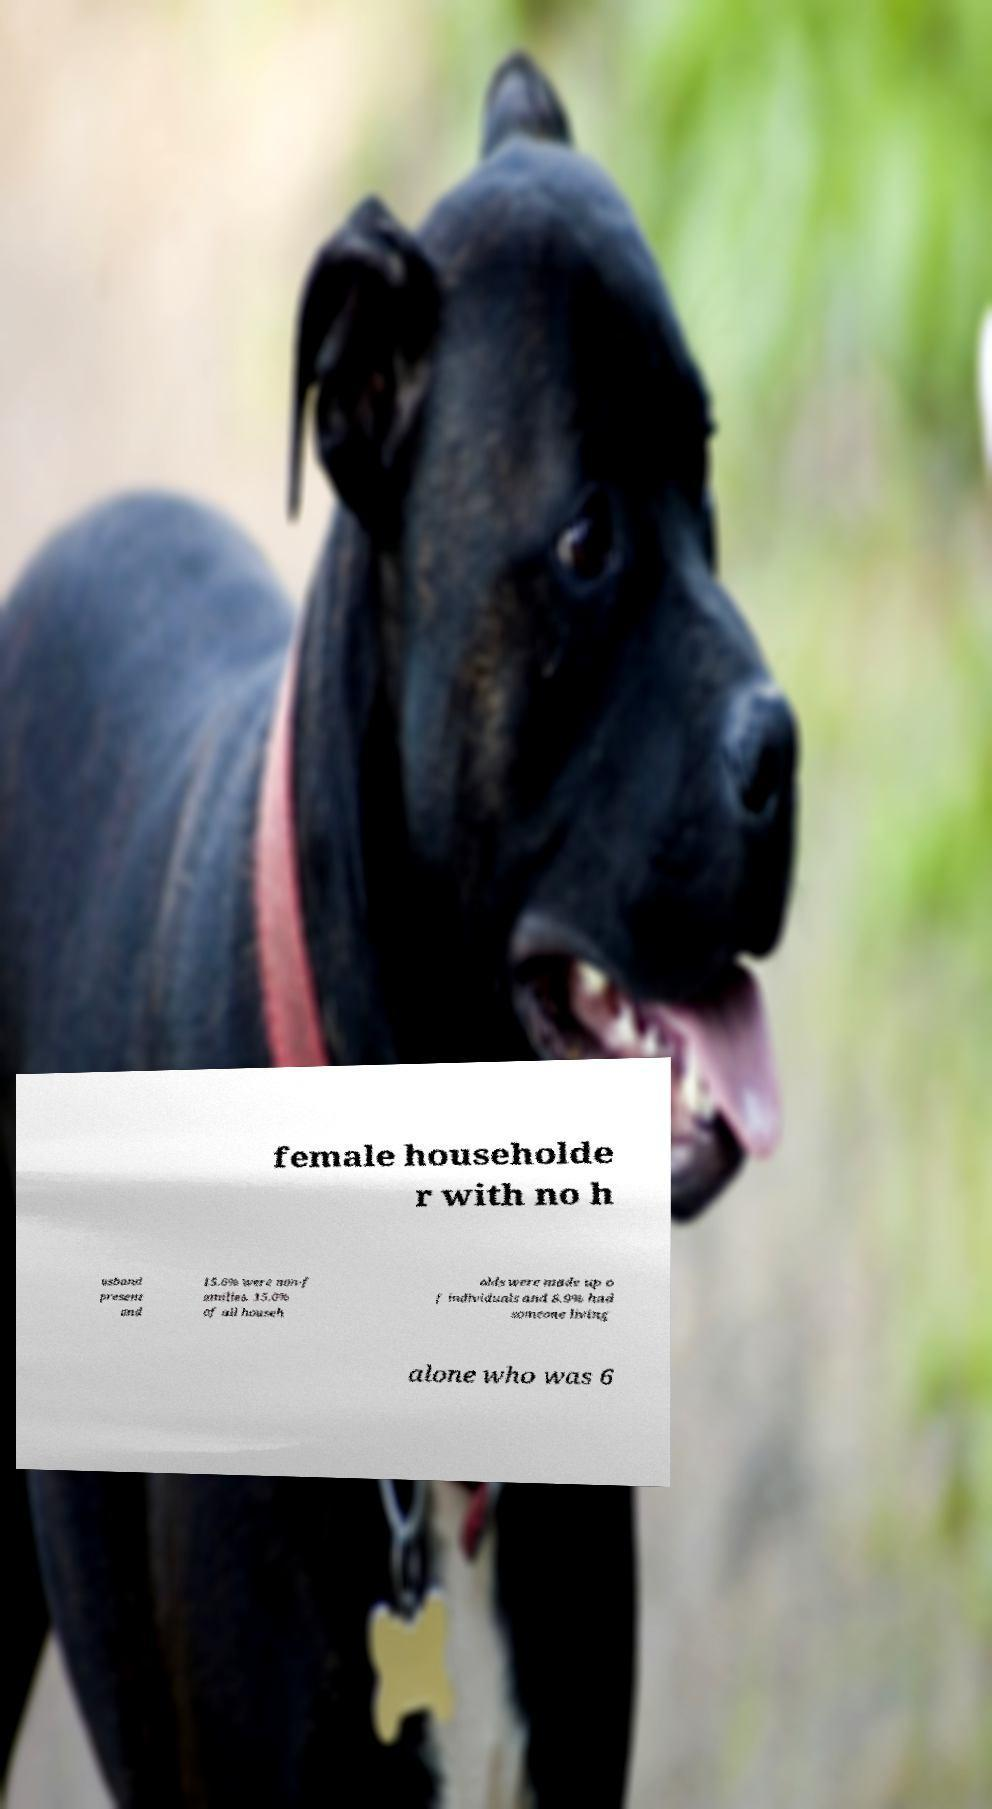Can you read and provide the text displayed in the image?This photo seems to have some interesting text. Can you extract and type it out for me? female householde r with no h usband present and 15.6% were non-f amilies. 15.0% of all househ olds were made up o f individuals and 8.9% had someone living alone who was 6 